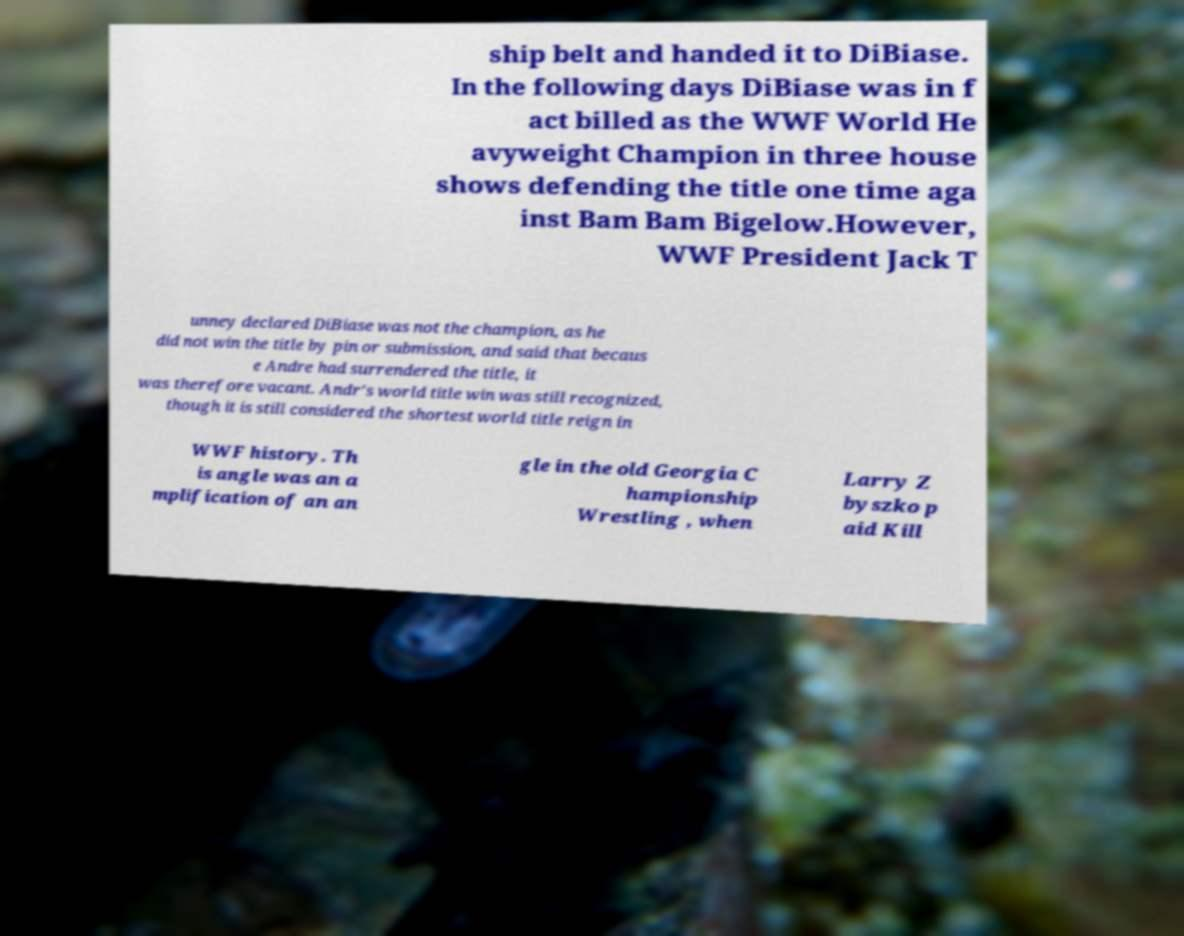Could you extract and type out the text from this image? ship belt and handed it to DiBiase. In the following days DiBiase was in f act billed as the WWF World He avyweight Champion in three house shows defending the title one time aga inst Bam Bam Bigelow.However, WWF President Jack T unney declared DiBiase was not the champion, as he did not win the title by pin or submission, and said that becaus e Andre had surrendered the title, it was therefore vacant. Andr's world title win was still recognized, though it is still considered the shortest world title reign in WWF history. Th is angle was an a mplification of an an gle in the old Georgia C hampionship Wrestling , when Larry Z byszko p aid Kill 